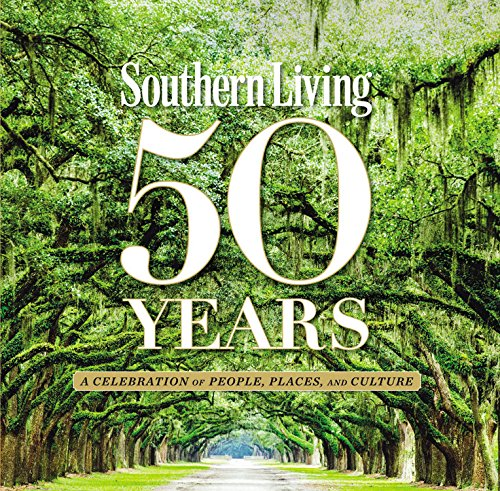Describe the type of recipes that might be found in this book. You can expect a wide variety of Southern dishes, from classic comfort foods like fried chicken and barbecue to traditional desserts such as pecan pies and cobblers. The recipes also emphasize local ingredients and seasonal cooking, offering readers a taste of true Southern hospitality and culture. 